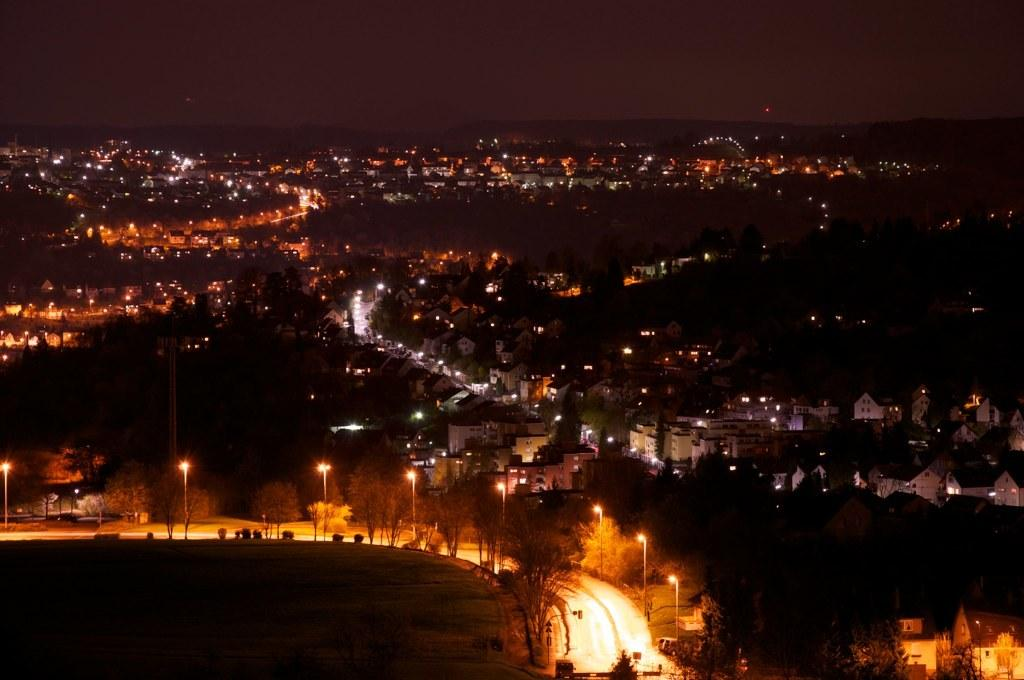What is the main feature of the image? There is a road in the image. What can be seen beside the road? There are street lights beside the road. What other structures are present in the image? There are buildings in the image. What type of vegetation is visible in the image? There are trees in the image. What is visible at the top of the image? The sky is visible at the top of the image. What type of force is being exerted on the buildings in the image? There is no indication of any force being exerted on the buildings in the image. Can you tell me how many quarters are visible in the image? There are no quarters present in the image. 